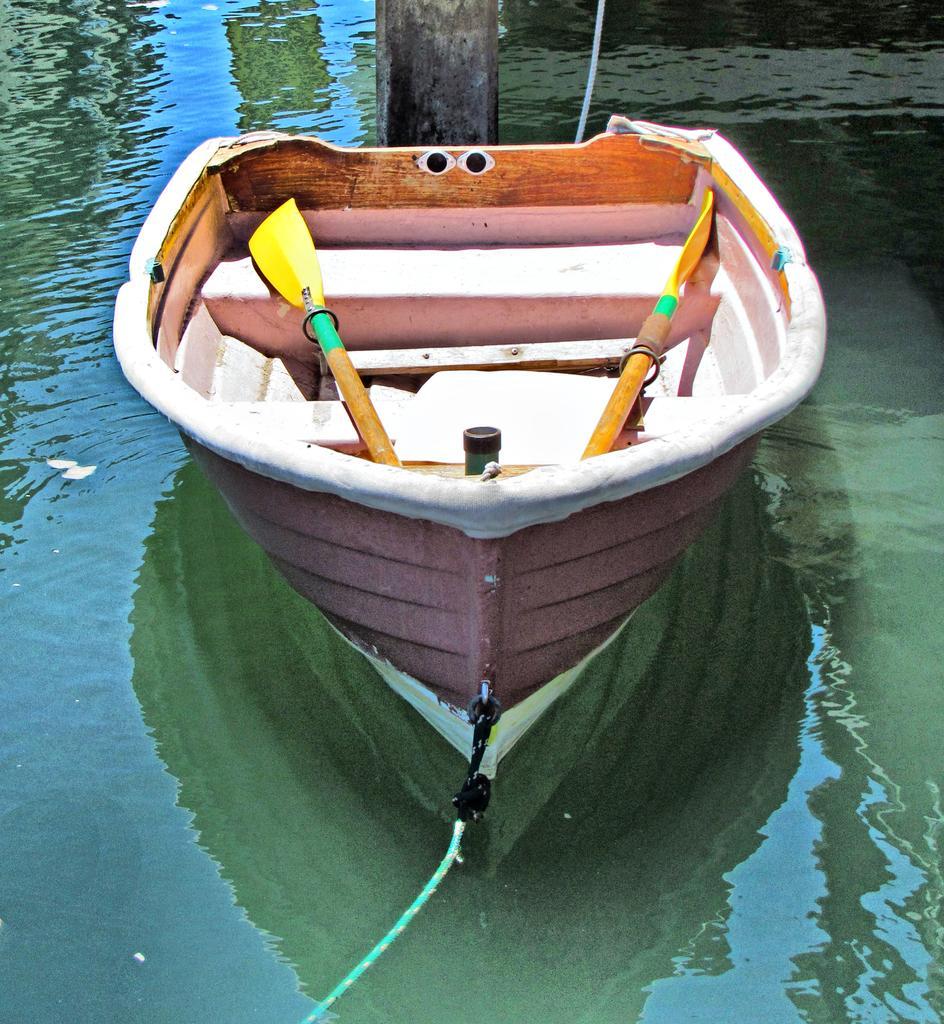In one or two sentences, can you explain what this image depicts? In this image, we can see canoe paddles in the boat and at the bottom, there is water. 